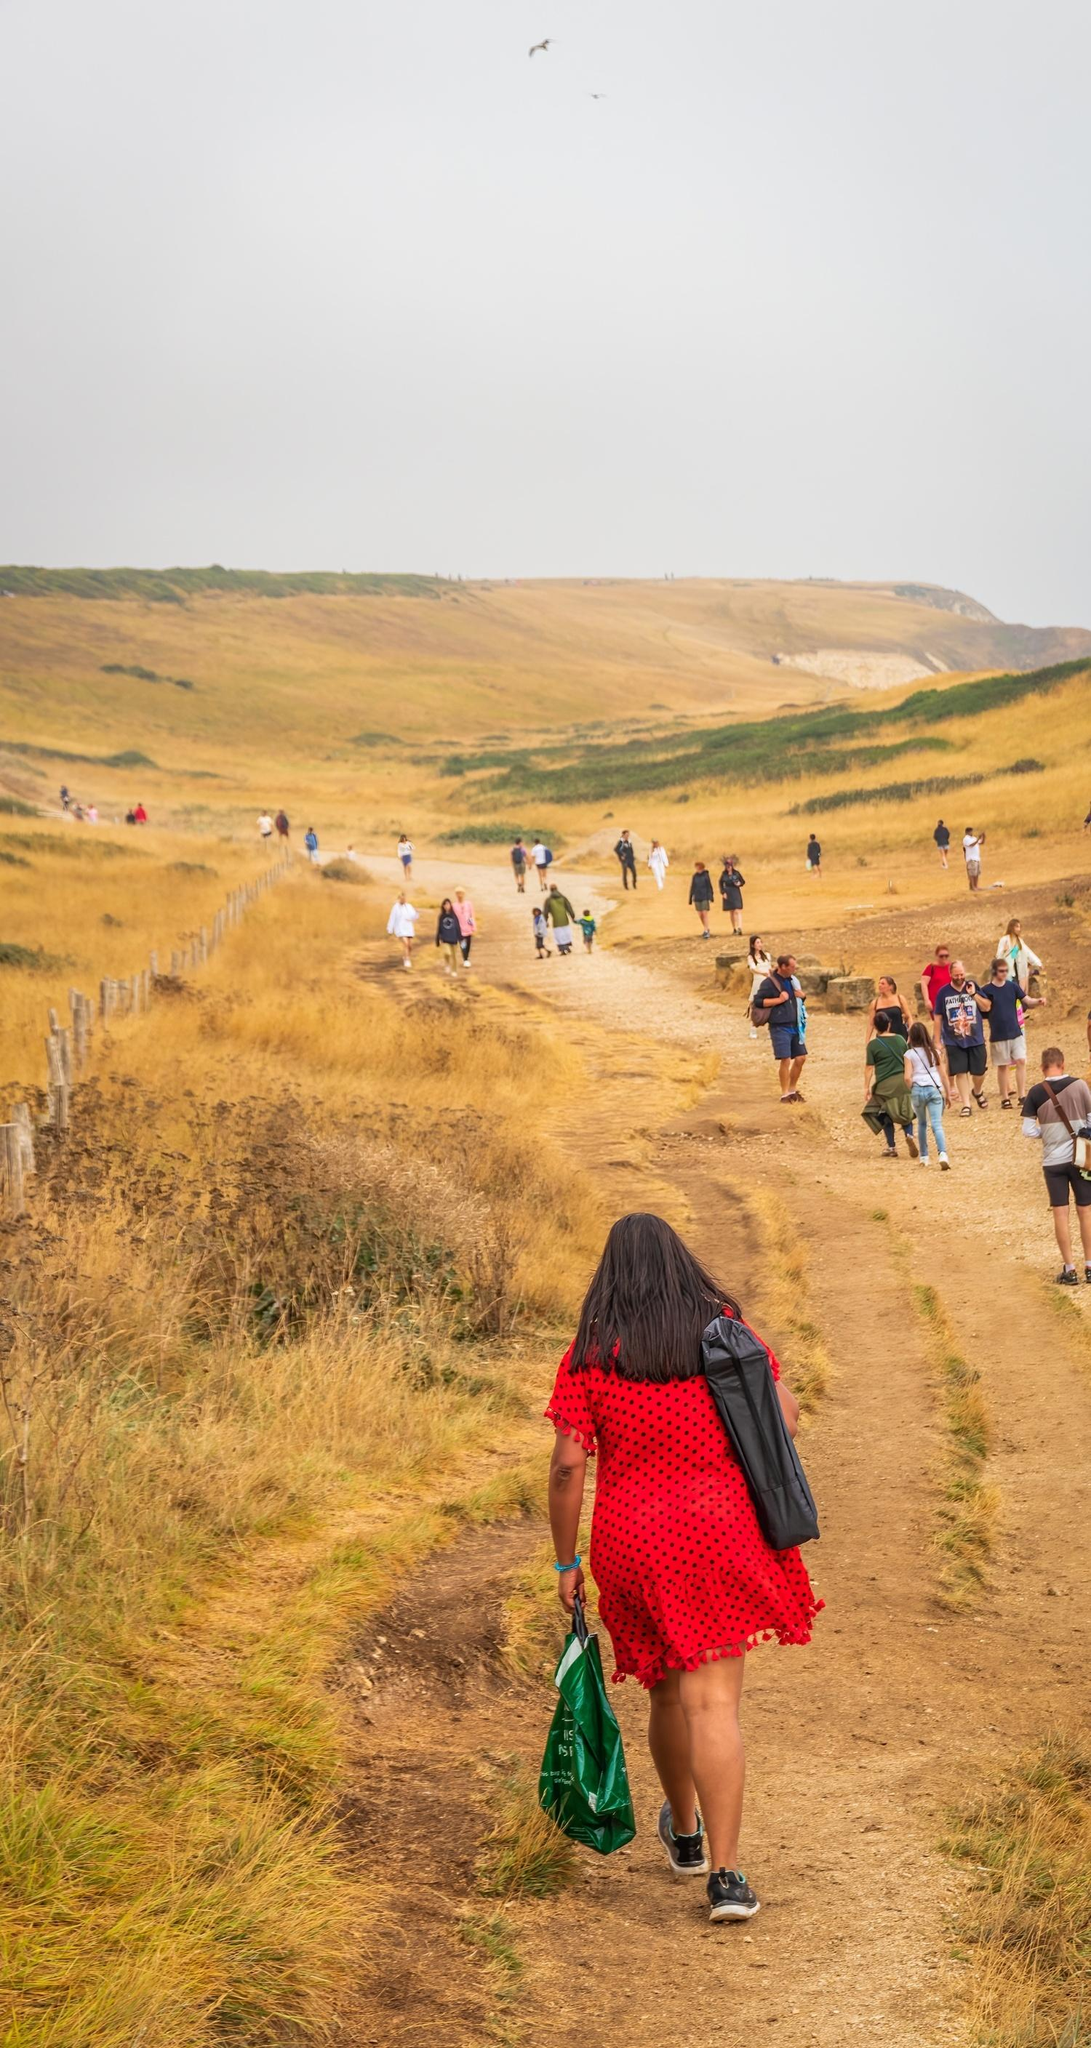Create an extremely detailed narrative as if writing the opening of a novel based on this image. In the gentle embrace of the rolling hills, where golden grass rustled softly in the breath of the countryside breeze, a band of wanderers took to the ancient dirt path, each step a silent yet harmonious cadence with the rhythm of the earth. This was no ordinary day, but a tapestry woven from threads of camaraderie and discovery.

At the forefront, a figure in a cherry-red dress forged ahead, her vibrant attire standing out like a vivid brushstroke against the muted canvas of the landscape. Her green bag, carried with a nonchalant ease, hinted at the treasures of a simple life - perhaps a packed lunch, a cherished book, or tools for observing the natural wonders around.

Behind her, the procession unfurled with casual grace, a string of souls bound by the shared spirit of exploration. Some walked in pairs, their low murmurs barely above whispers, weaving tales of past and future in the thin air. Children darted between the adults, their laughter a bright echo that leaped and danced, filling the spaces between moments.

The wooden fence, old and weathered, stood as a sentinel on one side, guarding the path and marking the boundary between the known realm of the human journey and the wild, untamed expanse beyond. On the other, hills rose gently, their gentle slopes a cradle for the body and the soul.

Above, the sky brooded with a quiet intensity. Overcast, it hinted at an impending change, a promise of soft rain or a brief sunlit respite. Birds, dark specks against the gray, soared with the abandon only creatures of the sky understood, as if guiding the travelers below to look up and find stories written in the clouds.

And so, the journey carried on, a living corridor of friendship, a route not merely through the physical terrain but through the intimate landscapes of their lives. This simple walk was a pilgrimage of sorts, a journey into the heart of nature and the depths of human connection, an adventure sculpted by the hand of time and the essence of shared experience. 